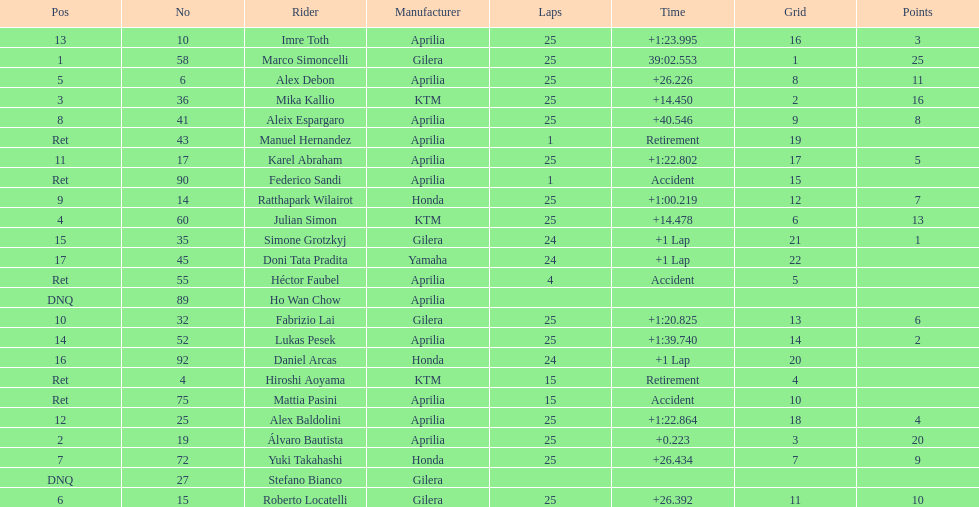What is the total number of laps performed by rider imre toth? 25. 